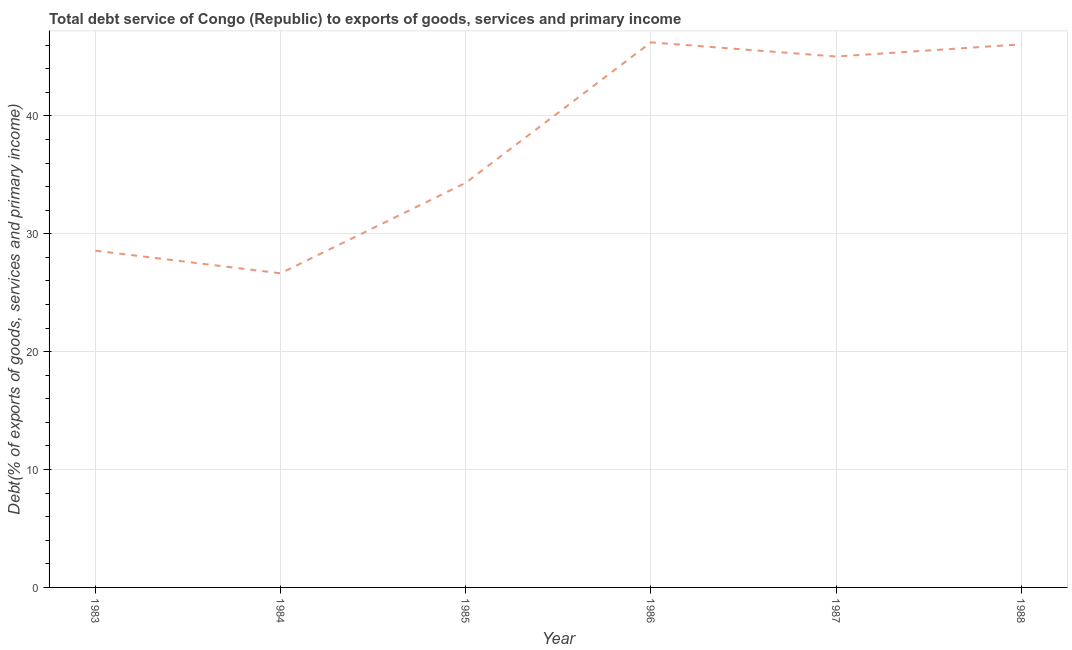What is the total debt service in 1984?
Give a very brief answer. 26.65. Across all years, what is the maximum total debt service?
Your answer should be very brief. 46.24. Across all years, what is the minimum total debt service?
Offer a very short reply. 26.65. In which year was the total debt service maximum?
Ensure brevity in your answer.  1986. In which year was the total debt service minimum?
Provide a short and direct response. 1984. What is the sum of the total debt service?
Offer a terse response. 226.87. What is the difference between the total debt service in 1984 and 1988?
Keep it short and to the point. -19.42. What is the average total debt service per year?
Provide a succinct answer. 37.81. What is the median total debt service?
Offer a very short reply. 39.68. In how many years, is the total debt service greater than 30 %?
Provide a short and direct response. 4. Do a majority of the years between 1987 and 1985 (inclusive) have total debt service greater than 32 %?
Make the answer very short. No. What is the ratio of the total debt service in 1983 to that in 1987?
Provide a succinct answer. 0.63. Is the total debt service in 1985 less than that in 1986?
Your answer should be very brief. Yes. What is the difference between the highest and the second highest total debt service?
Your response must be concise. 0.17. What is the difference between the highest and the lowest total debt service?
Your answer should be compact. 19.59. Does the total debt service monotonically increase over the years?
Provide a succinct answer. No. How many lines are there?
Your answer should be very brief. 1. How many years are there in the graph?
Offer a terse response. 6. What is the difference between two consecutive major ticks on the Y-axis?
Your answer should be compact. 10. Are the values on the major ticks of Y-axis written in scientific E-notation?
Your answer should be very brief. No. Does the graph contain any zero values?
Give a very brief answer. No. Does the graph contain grids?
Your response must be concise. Yes. What is the title of the graph?
Ensure brevity in your answer.  Total debt service of Congo (Republic) to exports of goods, services and primary income. What is the label or title of the Y-axis?
Ensure brevity in your answer.  Debt(% of exports of goods, services and primary income). What is the Debt(% of exports of goods, services and primary income) in 1983?
Ensure brevity in your answer.  28.56. What is the Debt(% of exports of goods, services and primary income) of 1984?
Your answer should be very brief. 26.65. What is the Debt(% of exports of goods, services and primary income) of 1985?
Offer a very short reply. 34.32. What is the Debt(% of exports of goods, services and primary income) of 1986?
Provide a succinct answer. 46.24. What is the Debt(% of exports of goods, services and primary income) of 1987?
Offer a very short reply. 45.03. What is the Debt(% of exports of goods, services and primary income) of 1988?
Your answer should be very brief. 46.07. What is the difference between the Debt(% of exports of goods, services and primary income) in 1983 and 1984?
Offer a terse response. 1.92. What is the difference between the Debt(% of exports of goods, services and primary income) in 1983 and 1985?
Your response must be concise. -5.76. What is the difference between the Debt(% of exports of goods, services and primary income) in 1983 and 1986?
Provide a short and direct response. -17.67. What is the difference between the Debt(% of exports of goods, services and primary income) in 1983 and 1987?
Give a very brief answer. -16.47. What is the difference between the Debt(% of exports of goods, services and primary income) in 1983 and 1988?
Give a very brief answer. -17.51. What is the difference between the Debt(% of exports of goods, services and primary income) in 1984 and 1985?
Make the answer very short. -7.67. What is the difference between the Debt(% of exports of goods, services and primary income) in 1984 and 1986?
Your answer should be compact. -19.59. What is the difference between the Debt(% of exports of goods, services and primary income) in 1984 and 1987?
Your response must be concise. -18.39. What is the difference between the Debt(% of exports of goods, services and primary income) in 1984 and 1988?
Provide a short and direct response. -19.42. What is the difference between the Debt(% of exports of goods, services and primary income) in 1985 and 1986?
Ensure brevity in your answer.  -11.91. What is the difference between the Debt(% of exports of goods, services and primary income) in 1985 and 1987?
Provide a succinct answer. -10.71. What is the difference between the Debt(% of exports of goods, services and primary income) in 1985 and 1988?
Provide a succinct answer. -11.75. What is the difference between the Debt(% of exports of goods, services and primary income) in 1986 and 1987?
Provide a short and direct response. 1.2. What is the difference between the Debt(% of exports of goods, services and primary income) in 1986 and 1988?
Keep it short and to the point. 0.17. What is the difference between the Debt(% of exports of goods, services and primary income) in 1987 and 1988?
Give a very brief answer. -1.03. What is the ratio of the Debt(% of exports of goods, services and primary income) in 1983 to that in 1984?
Ensure brevity in your answer.  1.07. What is the ratio of the Debt(% of exports of goods, services and primary income) in 1983 to that in 1985?
Your answer should be very brief. 0.83. What is the ratio of the Debt(% of exports of goods, services and primary income) in 1983 to that in 1986?
Give a very brief answer. 0.62. What is the ratio of the Debt(% of exports of goods, services and primary income) in 1983 to that in 1987?
Provide a succinct answer. 0.63. What is the ratio of the Debt(% of exports of goods, services and primary income) in 1983 to that in 1988?
Provide a short and direct response. 0.62. What is the ratio of the Debt(% of exports of goods, services and primary income) in 1984 to that in 1985?
Make the answer very short. 0.78. What is the ratio of the Debt(% of exports of goods, services and primary income) in 1984 to that in 1986?
Give a very brief answer. 0.58. What is the ratio of the Debt(% of exports of goods, services and primary income) in 1984 to that in 1987?
Give a very brief answer. 0.59. What is the ratio of the Debt(% of exports of goods, services and primary income) in 1984 to that in 1988?
Your answer should be compact. 0.58. What is the ratio of the Debt(% of exports of goods, services and primary income) in 1985 to that in 1986?
Your answer should be compact. 0.74. What is the ratio of the Debt(% of exports of goods, services and primary income) in 1985 to that in 1987?
Your answer should be compact. 0.76. What is the ratio of the Debt(% of exports of goods, services and primary income) in 1985 to that in 1988?
Ensure brevity in your answer.  0.74. What is the ratio of the Debt(% of exports of goods, services and primary income) in 1987 to that in 1988?
Provide a short and direct response. 0.98. 